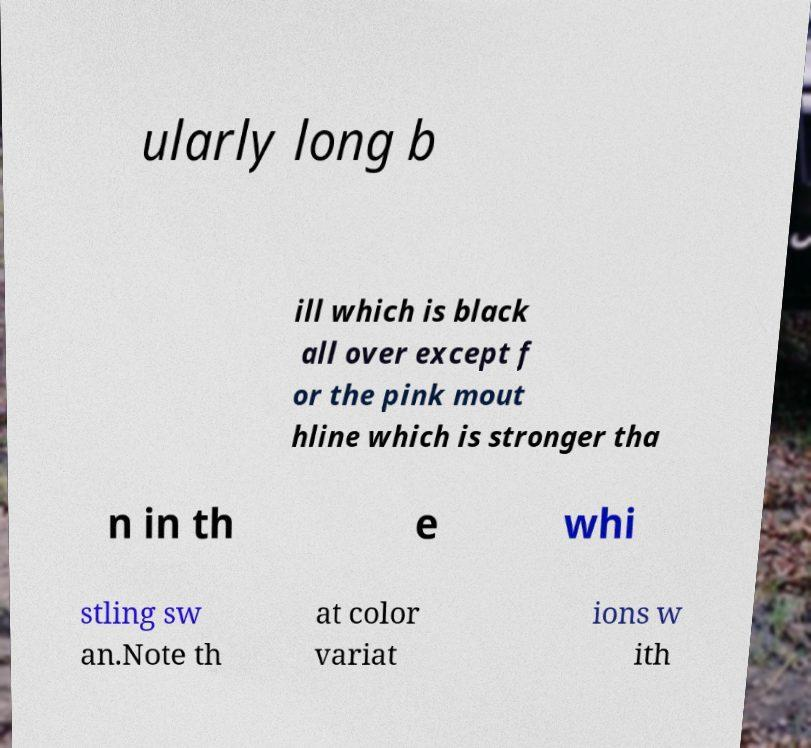Can you read and provide the text displayed in the image?This photo seems to have some interesting text. Can you extract and type it out for me? ularly long b ill which is black all over except f or the pink mout hline which is stronger tha n in th e whi stling sw an.Note th at color variat ions w ith 